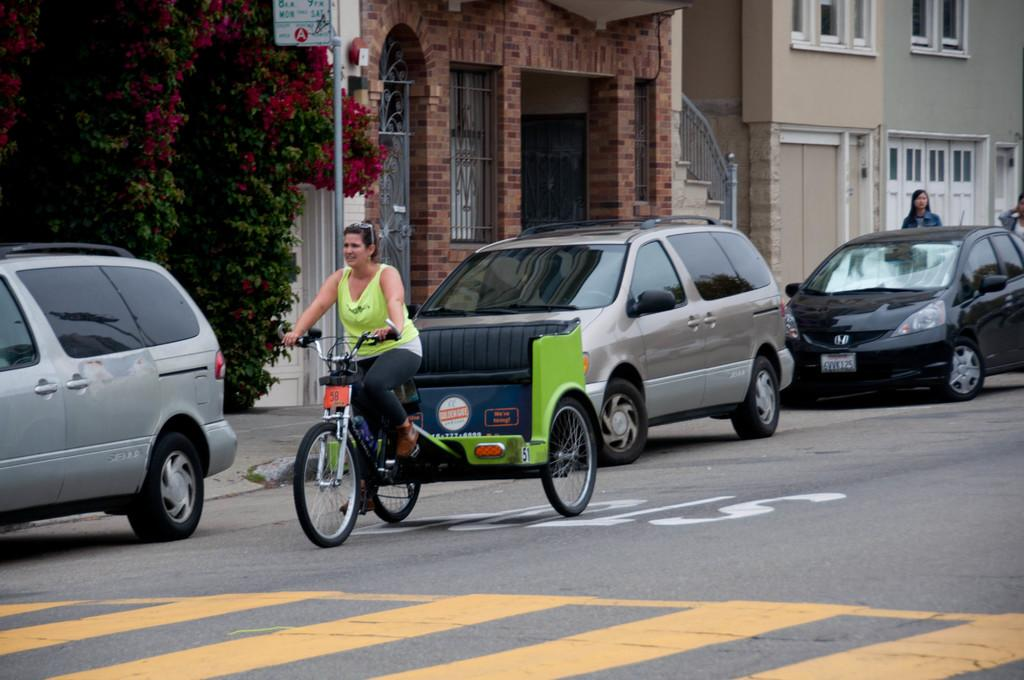Who is the main subject in the image? There is a woman in the image. What is the woman doing in the image? The woman is cycling on the road. Are there any vehicles in the image? Yes, there are cars behind the woman. What can be seen in the background of the image? There are buildings and trees in the background of the image. How many fish can be seen swimming in the background of the image? There are no fish present in the image; it features a woman cycling on the road with buildings and trees in the background. 